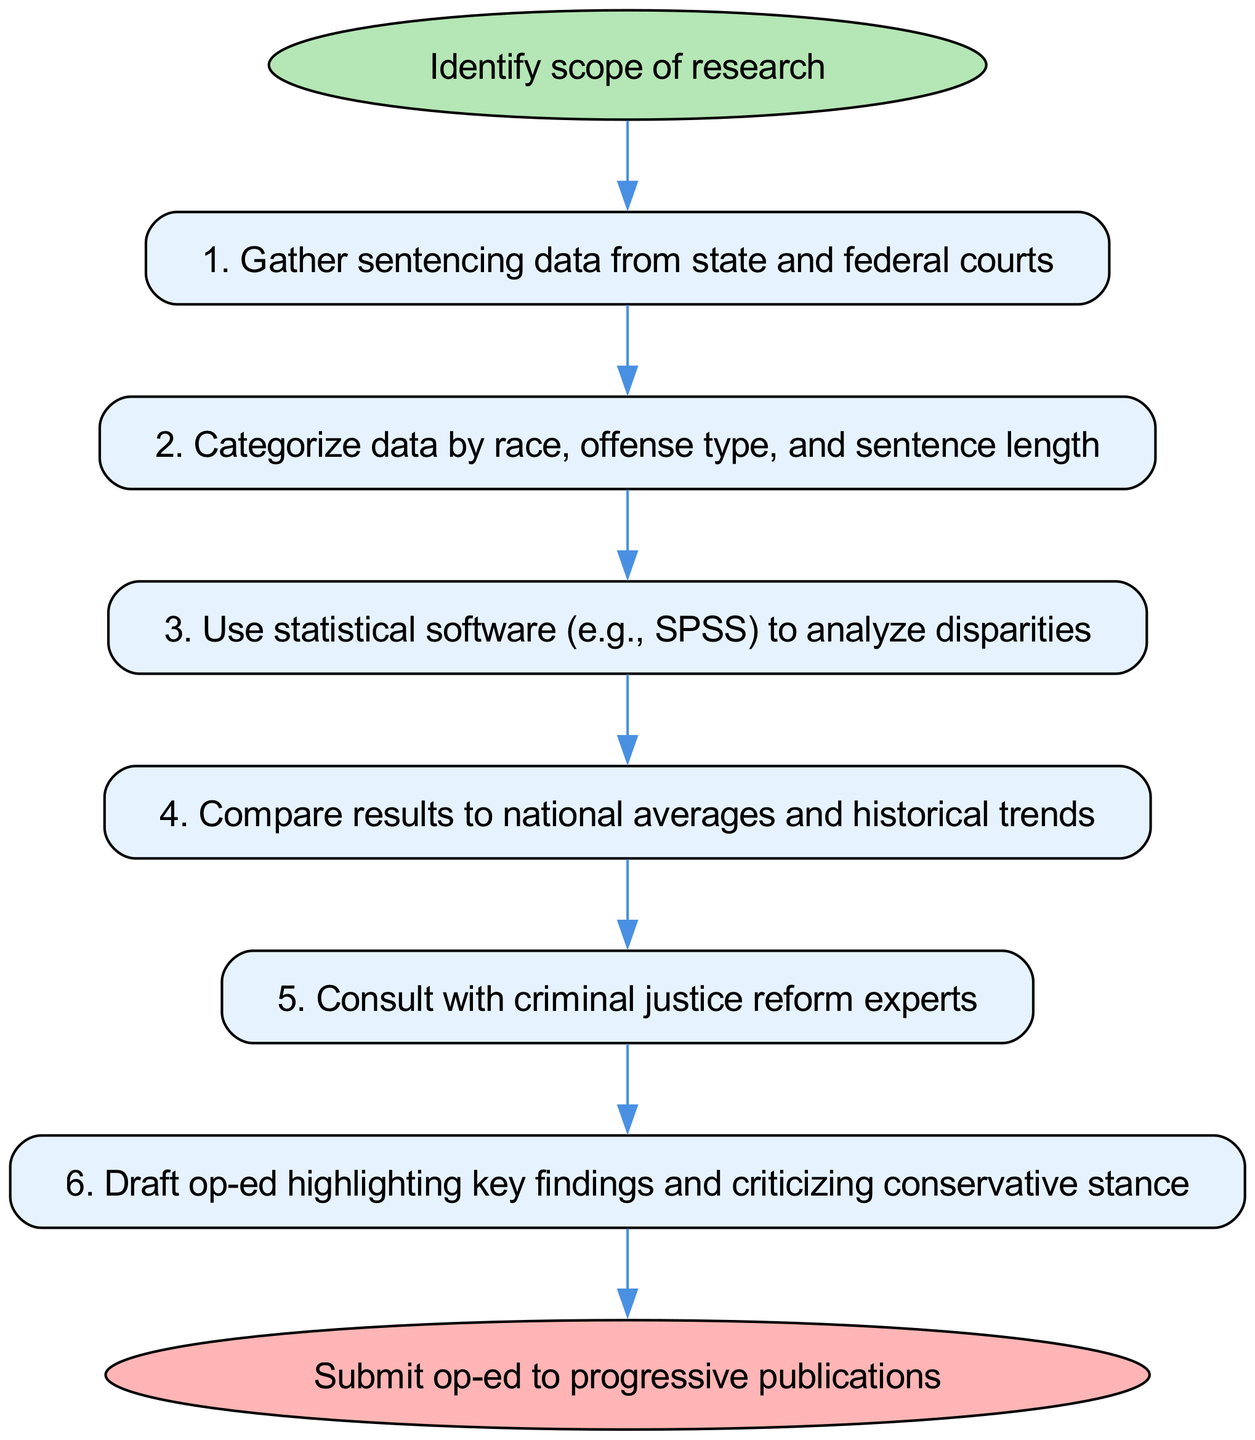What is the first step in the workflow? The workflow begins with identifying the scope of research, as indicated by the first node after the start.
Answer: Identify scope of research How many nodes are there in total? The diagram contains seven nodes, including the start and end nodes, plus five process nodes in between.
Answer: Seven What type of data is being gathered in the second step? The second step involves gathering sentencing data, specifying that it is sourced from state and federal courts.
Answer: Sentencing data Which step involves statistical analysis? The third step mentions using statistical software (e.g., SPSS) to analyze disparities in the data which indicates the processes of analyzing racial disparities.
Answer: Use statistical software to analyze disparities What is the relationship between the fourth step and the fifth step? The fourth step compares results to national averages and historical trends, which directly leads into the fifth step where consultation with criminal justice reform experts takes place to further inform the analysis.
Answer: Fourth step leads to fifth step What is being submitted at the end of the workflow? At the end of the workflow, the diagram indicates that the op-ed highlighting key findings is submitted to progressive publications, completing the instruction process.
Answer: Op-ed to progressive publications What is the last step before submitting the op-ed? The sixth step focuses on drafting the op-ed based on the findings of the analysis and consultations, which is necessary before submission.
Answer: Draft op-ed Which step follows after comparing the results in step four? After comparing results in step four, the next step is consulting with criminal justice reform experts.
Answer: Consult with criminal justice reform experts 